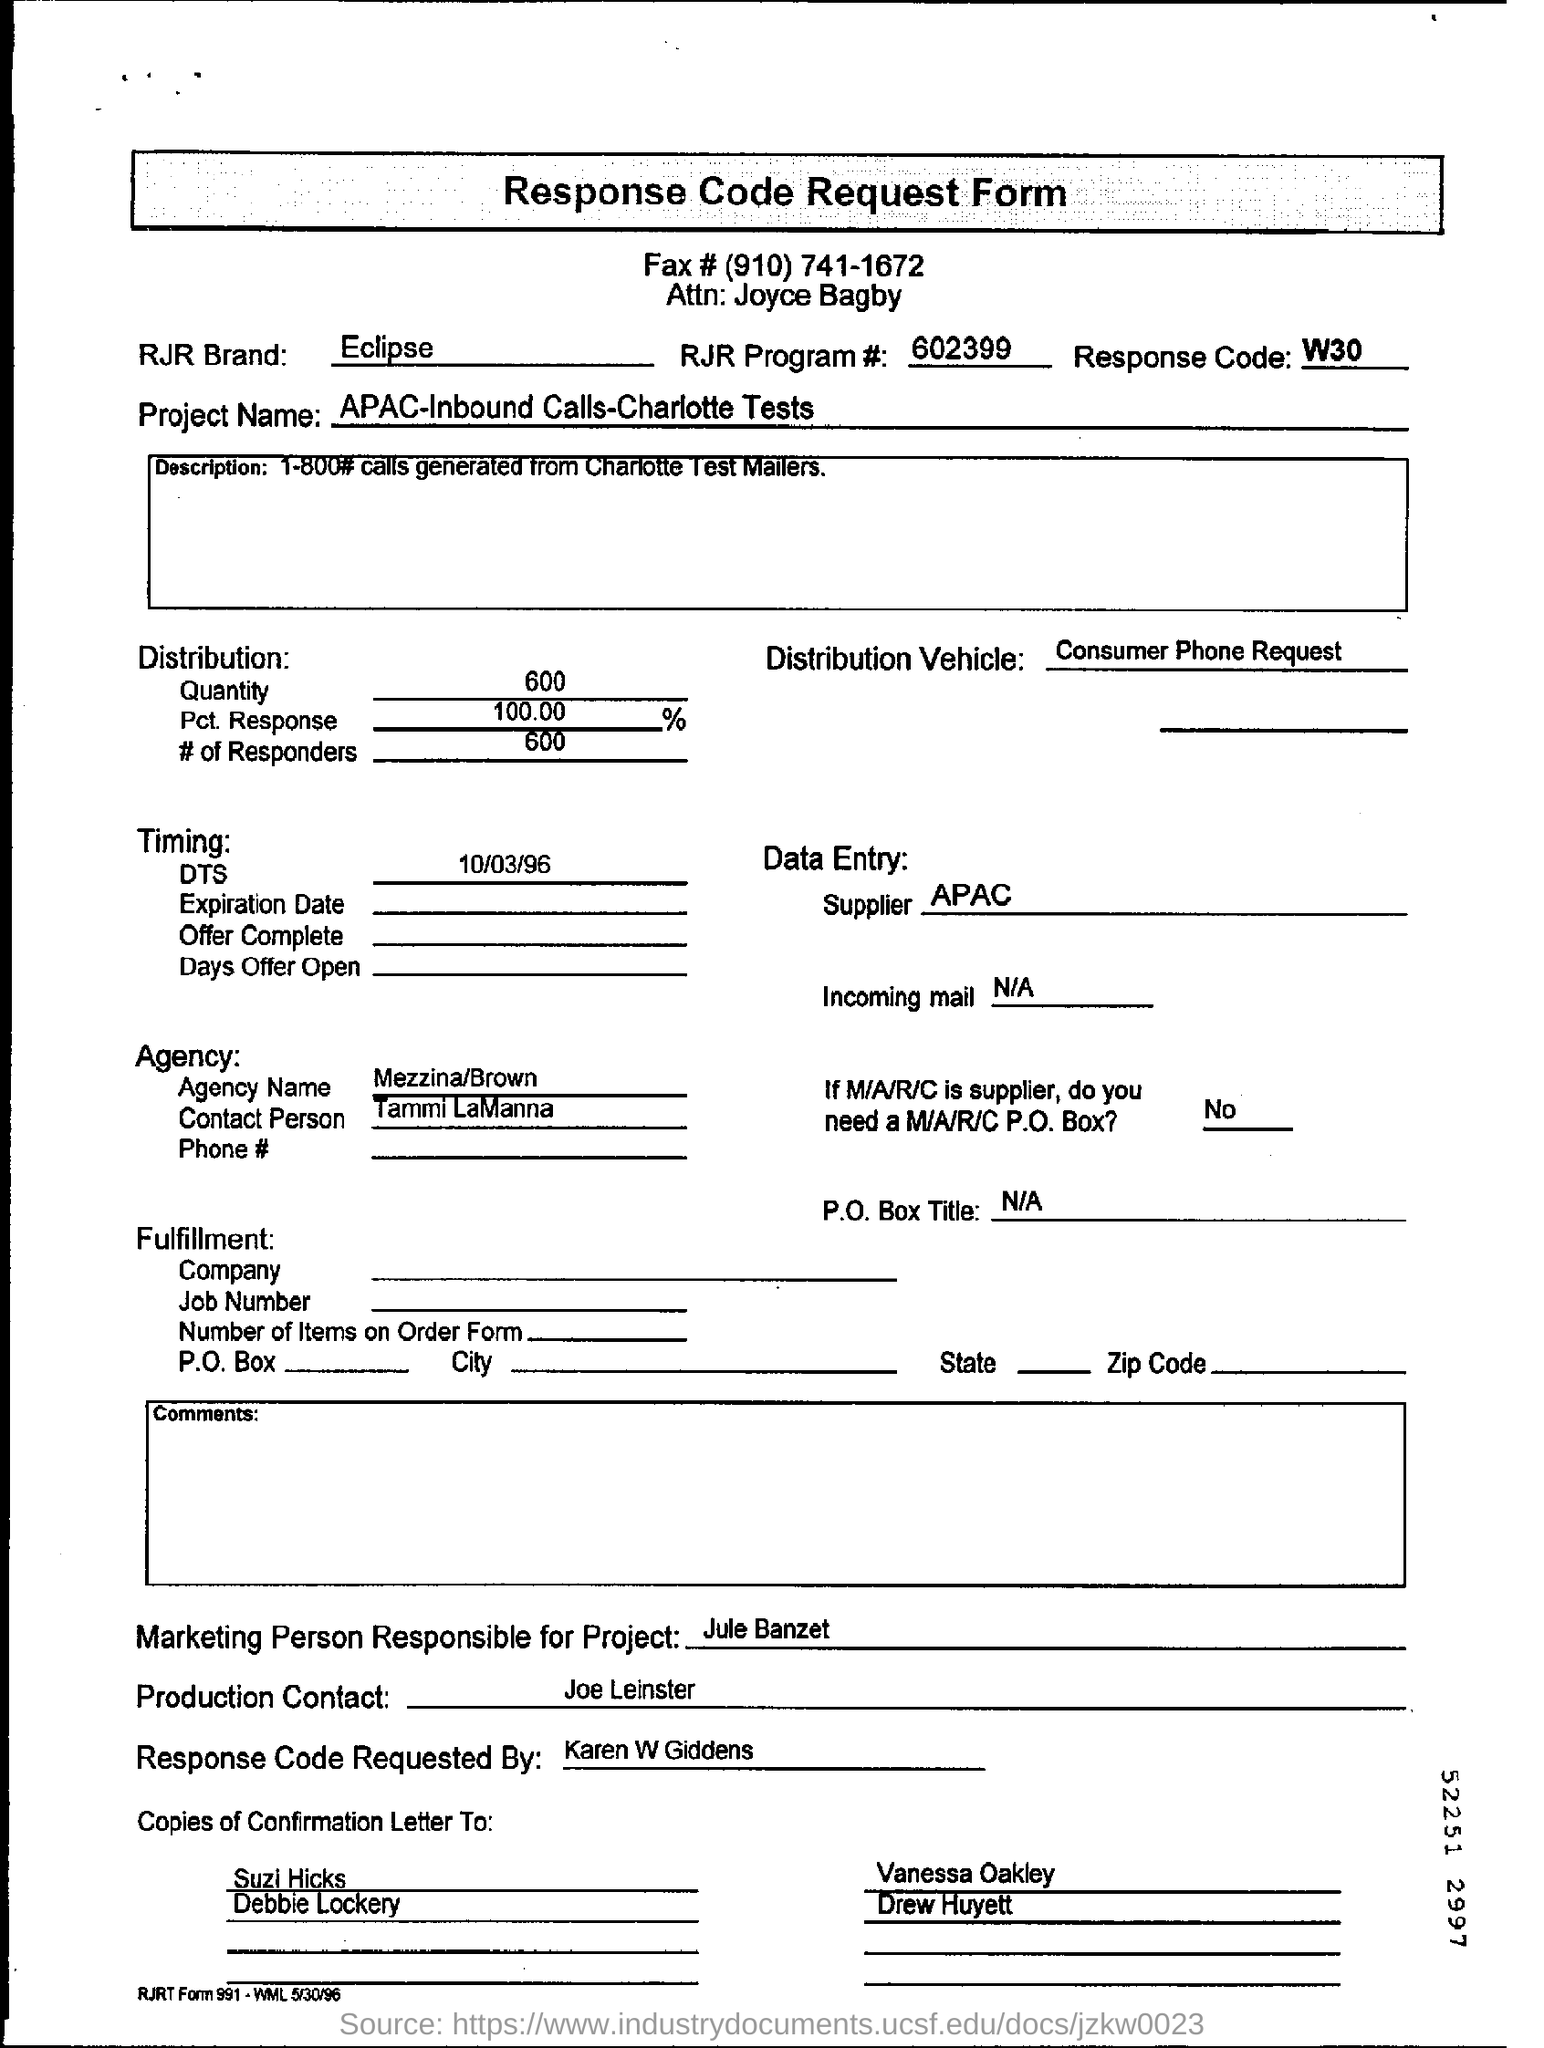Who is the Data Entry supplier?
Ensure brevity in your answer.  APAC. Who is the Marketing Person Responsibe for Project?
Make the answer very short. Jule Banzet. By whom is the Response Code requested?
Provide a succinct answer. Karen W Giddens. 